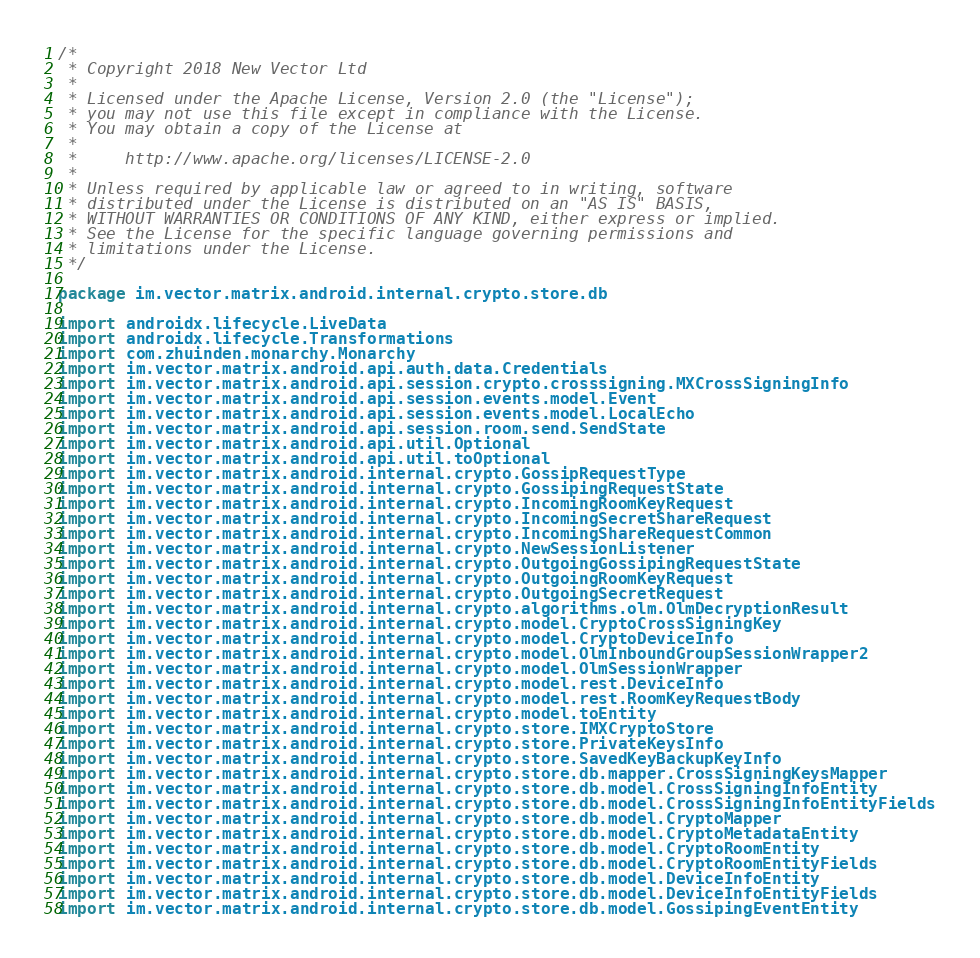<code> <loc_0><loc_0><loc_500><loc_500><_Kotlin_>/*
 * Copyright 2018 New Vector Ltd
 *
 * Licensed under the Apache License, Version 2.0 (the "License");
 * you may not use this file except in compliance with the License.
 * You may obtain a copy of the License at
 *
 *     http://www.apache.org/licenses/LICENSE-2.0
 *
 * Unless required by applicable law or agreed to in writing, software
 * distributed under the License is distributed on an "AS IS" BASIS,
 * WITHOUT WARRANTIES OR CONDITIONS OF ANY KIND, either express or implied.
 * See the License for the specific language governing permissions and
 * limitations under the License.
 */

package im.vector.matrix.android.internal.crypto.store.db

import androidx.lifecycle.LiveData
import androidx.lifecycle.Transformations
import com.zhuinden.monarchy.Monarchy
import im.vector.matrix.android.api.auth.data.Credentials
import im.vector.matrix.android.api.session.crypto.crosssigning.MXCrossSigningInfo
import im.vector.matrix.android.api.session.events.model.Event
import im.vector.matrix.android.api.session.events.model.LocalEcho
import im.vector.matrix.android.api.session.room.send.SendState
import im.vector.matrix.android.api.util.Optional
import im.vector.matrix.android.api.util.toOptional
import im.vector.matrix.android.internal.crypto.GossipRequestType
import im.vector.matrix.android.internal.crypto.GossipingRequestState
import im.vector.matrix.android.internal.crypto.IncomingRoomKeyRequest
import im.vector.matrix.android.internal.crypto.IncomingSecretShareRequest
import im.vector.matrix.android.internal.crypto.IncomingShareRequestCommon
import im.vector.matrix.android.internal.crypto.NewSessionListener
import im.vector.matrix.android.internal.crypto.OutgoingGossipingRequestState
import im.vector.matrix.android.internal.crypto.OutgoingRoomKeyRequest
import im.vector.matrix.android.internal.crypto.OutgoingSecretRequest
import im.vector.matrix.android.internal.crypto.algorithms.olm.OlmDecryptionResult
import im.vector.matrix.android.internal.crypto.model.CryptoCrossSigningKey
import im.vector.matrix.android.internal.crypto.model.CryptoDeviceInfo
import im.vector.matrix.android.internal.crypto.model.OlmInboundGroupSessionWrapper2
import im.vector.matrix.android.internal.crypto.model.OlmSessionWrapper
import im.vector.matrix.android.internal.crypto.model.rest.DeviceInfo
import im.vector.matrix.android.internal.crypto.model.rest.RoomKeyRequestBody
import im.vector.matrix.android.internal.crypto.model.toEntity
import im.vector.matrix.android.internal.crypto.store.IMXCryptoStore
import im.vector.matrix.android.internal.crypto.store.PrivateKeysInfo
import im.vector.matrix.android.internal.crypto.store.SavedKeyBackupKeyInfo
import im.vector.matrix.android.internal.crypto.store.db.mapper.CrossSigningKeysMapper
import im.vector.matrix.android.internal.crypto.store.db.model.CrossSigningInfoEntity
import im.vector.matrix.android.internal.crypto.store.db.model.CrossSigningInfoEntityFields
import im.vector.matrix.android.internal.crypto.store.db.model.CryptoMapper
import im.vector.matrix.android.internal.crypto.store.db.model.CryptoMetadataEntity
import im.vector.matrix.android.internal.crypto.store.db.model.CryptoRoomEntity
import im.vector.matrix.android.internal.crypto.store.db.model.CryptoRoomEntityFields
import im.vector.matrix.android.internal.crypto.store.db.model.DeviceInfoEntity
import im.vector.matrix.android.internal.crypto.store.db.model.DeviceInfoEntityFields
import im.vector.matrix.android.internal.crypto.store.db.model.GossipingEventEntity</code> 